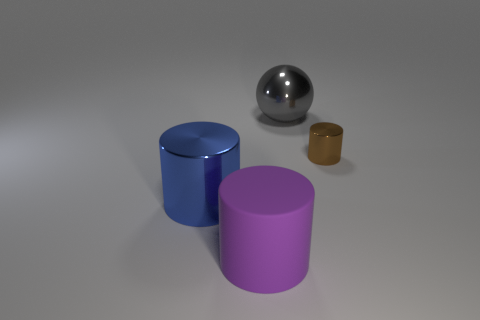There is a big metallic object that is left of the large metal object that is right of the rubber cylinder; what shape is it?
Ensure brevity in your answer.  Cylinder. The large matte thing is what shape?
Your answer should be compact. Cylinder. What material is the large cylinder in front of the large metallic thing on the left side of the shiny thing behind the tiny brown thing?
Your answer should be compact. Rubber. How many other objects are there of the same material as the large blue thing?
Provide a short and direct response. 2. How many purple rubber cylinders are to the left of the shiny cylinder on the right side of the shiny ball?
Your response must be concise. 1. How many cubes are tiny shiny objects or blue things?
Provide a succinct answer. 0. There is a metallic thing that is left of the brown cylinder and behind the large blue cylinder; what color is it?
Offer a very short reply. Gray. The object that is left of the large object in front of the blue shiny thing is what color?
Keep it short and to the point. Blue. Is the size of the gray metal ball the same as the blue metal cylinder?
Ensure brevity in your answer.  Yes. Are the thing that is to the right of the large sphere and the large thing in front of the big blue object made of the same material?
Ensure brevity in your answer.  No. 